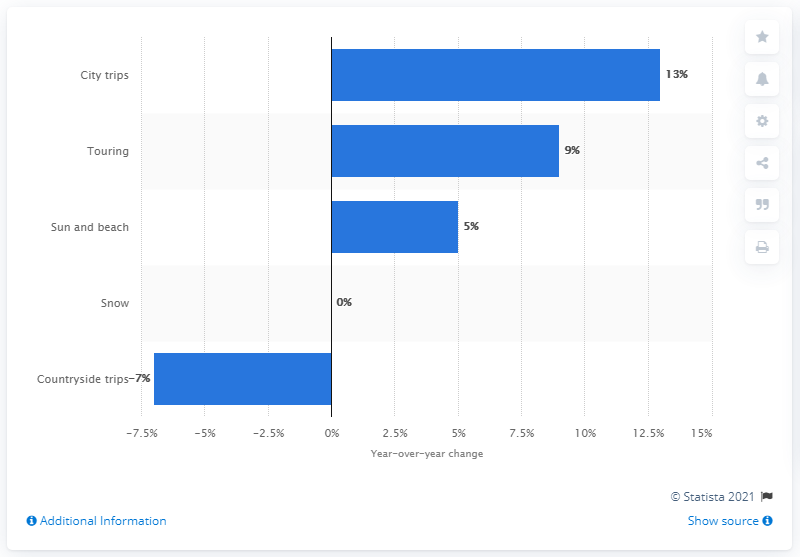Draw attention to some important aspects in this diagram. According to the data, the number of city trips taken by North Americans increased by 13% in the first eight months of 2014. 